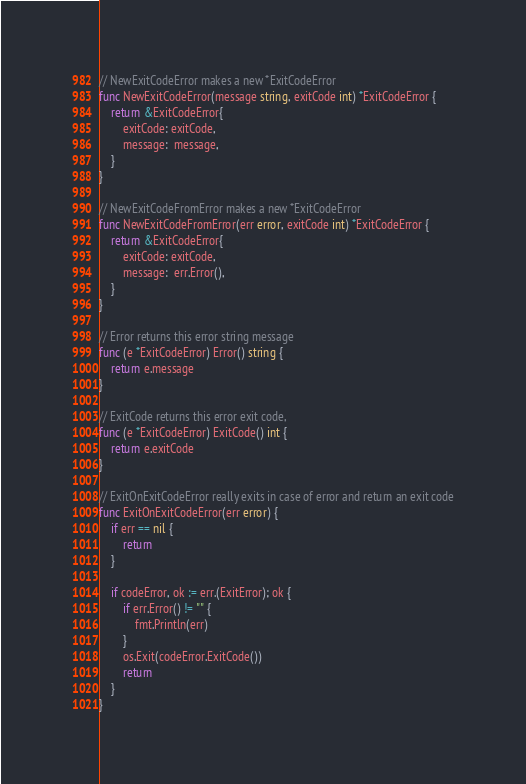<code> <loc_0><loc_0><loc_500><loc_500><_Go_>// NewExitCodeError makes a new *ExitCodeError
func NewExitCodeError(message string, exitCode int) *ExitCodeError {
	return &ExitCodeError{
		exitCode: exitCode,
		message:  message,
	}
}

// NewExitCodeFromError makes a new *ExitCodeError
func NewExitCodeFromError(err error, exitCode int) *ExitCodeError {
	return &ExitCodeError{
		exitCode: exitCode,
		message:  err.Error(),
	}
}

// Error returns this error string message
func (e *ExitCodeError) Error() string {
	return e.message
}

// ExitCode returns this error exit code,
func (e *ExitCodeError) ExitCode() int {
	return e.exitCode
}

// ExitOnExitCodeError really exits in case of error and return an exit code
func ExitOnExitCodeError(err error) {
	if err == nil {
		return
	}

	if codeError, ok := err.(ExitError); ok {
		if err.Error() != "" {
			fmt.Println(err)
		}
		os.Exit(codeError.ExitCode())
		return
	}
}
</code> 